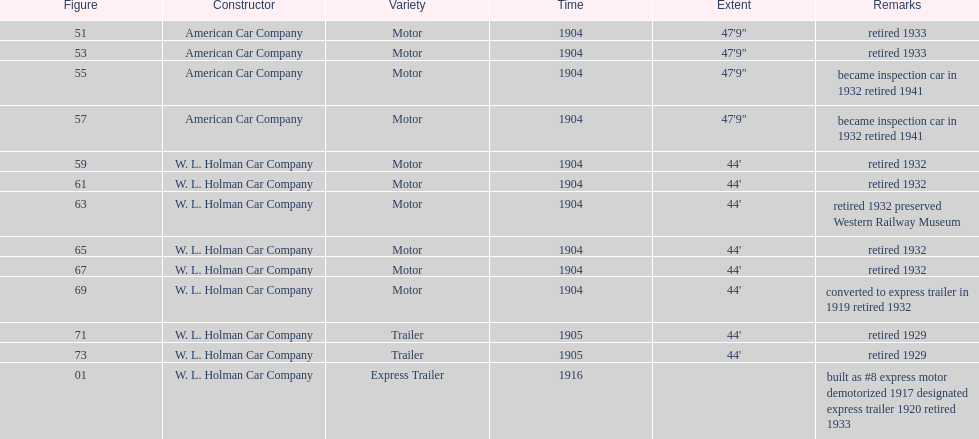Can you give me this table as a dict? {'header': ['Figure', 'Constructor', 'Variety', 'Time', 'Extent', 'Remarks'], 'rows': [['51', 'American Car Company', 'Motor', '1904', '47\'9"', 'retired 1933'], ['53', 'American Car Company', 'Motor', '1904', '47\'9"', 'retired 1933'], ['55', 'American Car Company', 'Motor', '1904', '47\'9"', 'became inspection car in 1932 retired 1941'], ['57', 'American Car Company', 'Motor', '1904', '47\'9"', 'became inspection car in 1932 retired 1941'], ['59', 'W. L. Holman Car Company', 'Motor', '1904', "44'", 'retired 1932'], ['61', 'W. L. Holman Car Company', 'Motor', '1904', "44'", 'retired 1932'], ['63', 'W. L. Holman Car Company', 'Motor', '1904', "44'", 'retired 1932 preserved Western Railway Museum'], ['65', 'W. L. Holman Car Company', 'Motor', '1904', "44'", 'retired 1932'], ['67', 'W. L. Holman Car Company', 'Motor', '1904', "44'", 'retired 1932'], ['69', 'W. L. Holman Car Company', 'Motor', '1904', "44'", 'converted to express trailer in 1919 retired 1932'], ['71', 'W. L. Holman Car Company', 'Trailer', '1905', "44'", 'retired 1929'], ['73', 'W. L. Holman Car Company', 'Trailer', '1905', "44'", 'retired 1929'], ['01', 'W. L. Holman Car Company', 'Express Trailer', '1916', '', 'built as #8 express motor demotorized 1917 designated express trailer 1920 retired 1933']]} In 1906, how many total rolling stock vehicles were in service? 12. 